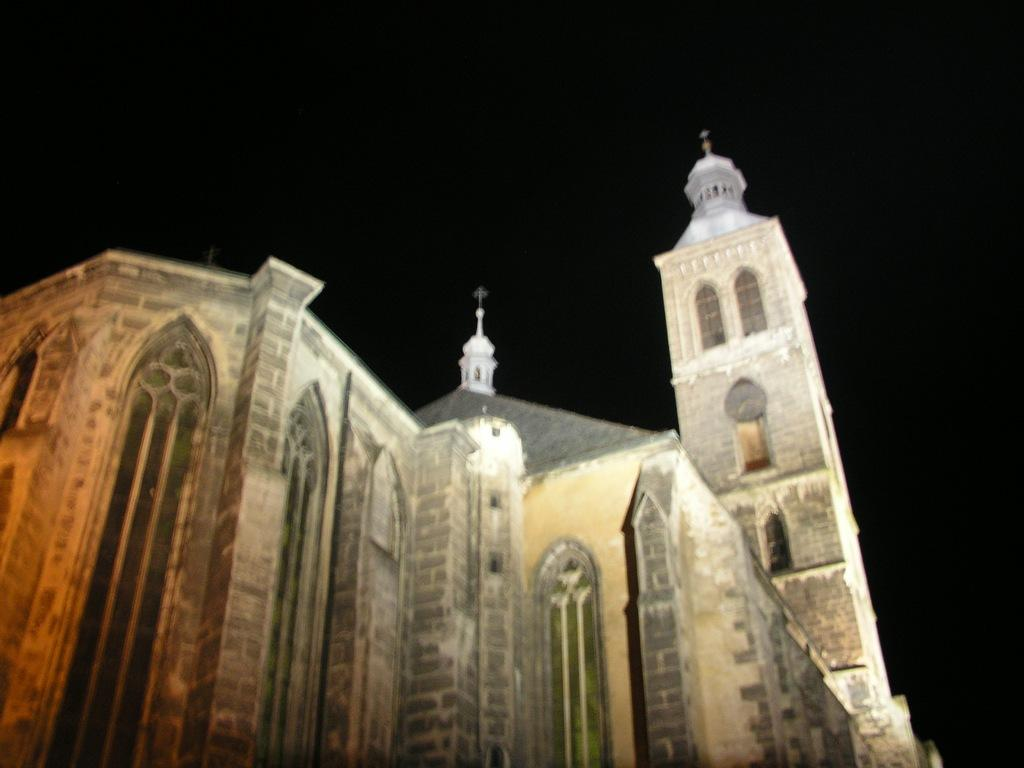What type of structure is visible in the image? There is a building in the image. What are some features of the building? The building has walls, pillars, windows, and roofs. Can you describe the background of the image? The background of the image is black. What type of breakfast is being served in the building in the image? There is no indication of any breakfast being served in the image, as it only shows the exterior of a building with specific architectural features. 